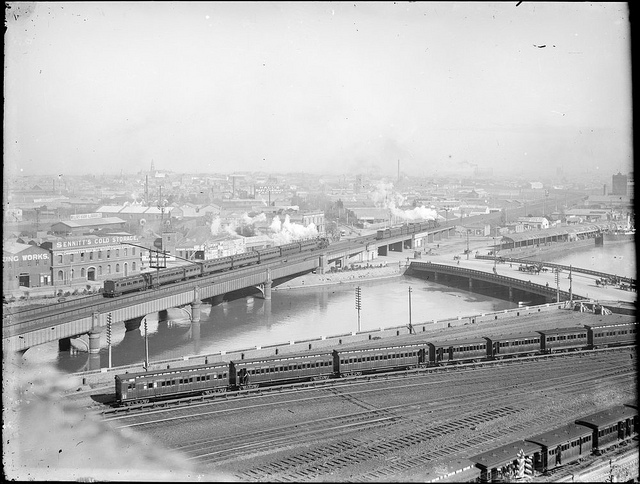Identify the text displayed in this image. COLD TORKS 